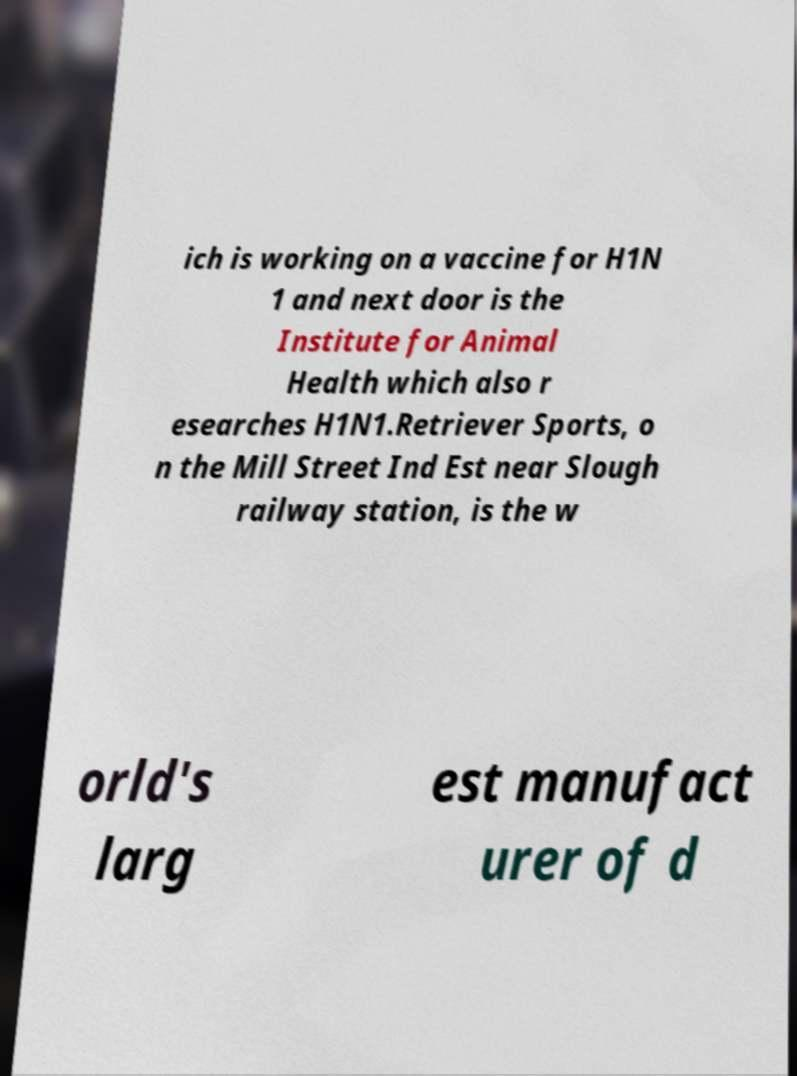Can you read and provide the text displayed in the image?This photo seems to have some interesting text. Can you extract and type it out for me? ich is working on a vaccine for H1N 1 and next door is the Institute for Animal Health which also r esearches H1N1.Retriever Sports, o n the Mill Street Ind Est near Slough railway station, is the w orld's larg est manufact urer of d 